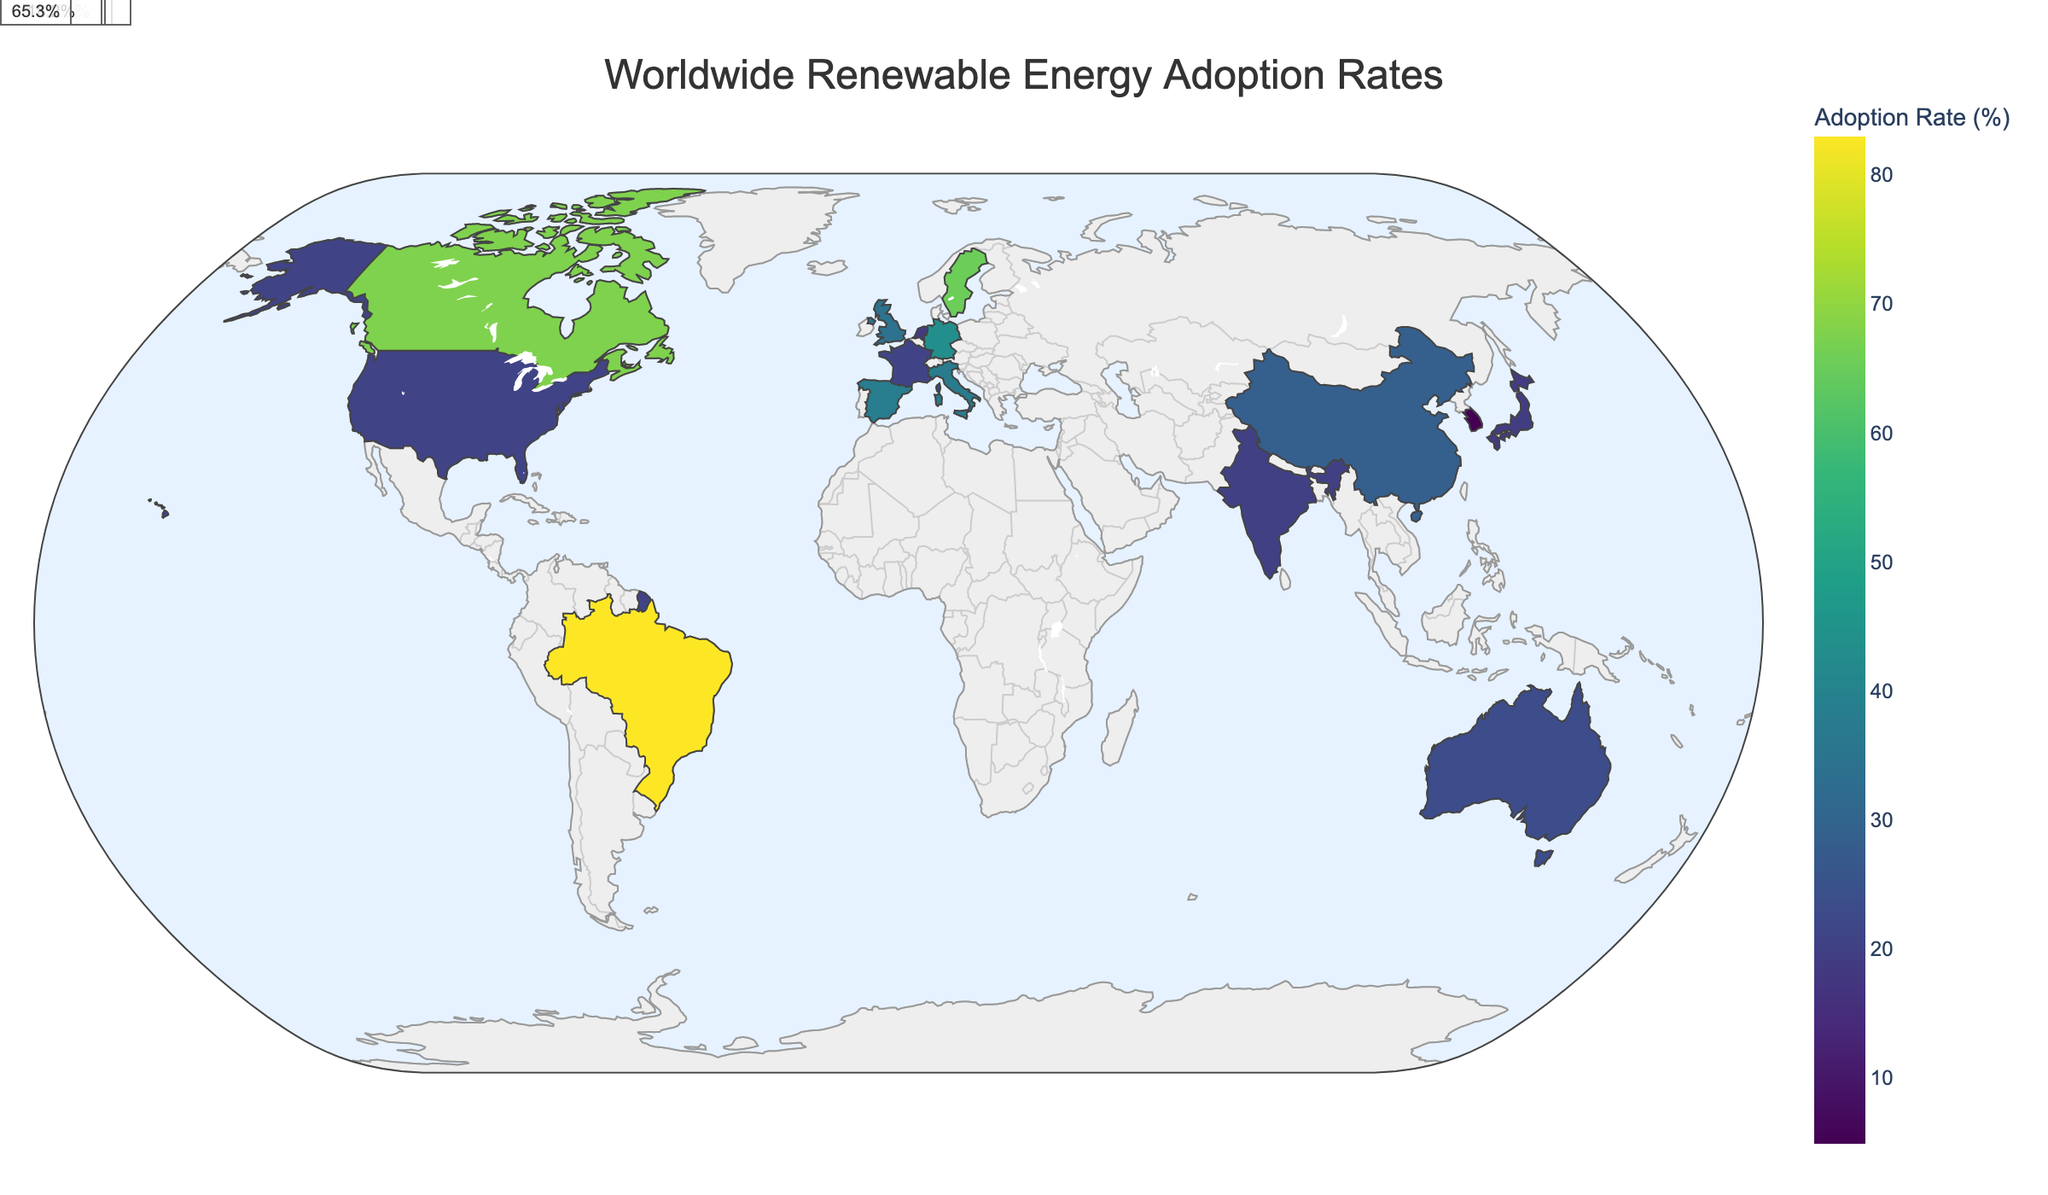what is the title of the figure? The title is positioned at the top of the figure and is intended to provide a brief summary of what the figure is depicting. In this case, it summarizes the geographical map showing renewable energy adoption rates around the world.
Answer: Worldwide Renewable Energy Adoption Rates Which country has the highest total renewable energy adoption rate? To find the highest total renewable energy adoption rate, look at the color intensity and the annotations for total adoption rates. The darker the color, the higher the rate. Brazil appears to have the highest percentage.
Answer: Brazil How does the renewable energy adoption rate of Germany compare to that of the United States? First, locate Germany and the United States on the map. Germany appears to have a more intense color and a higher annotated figure compared to the United States. Germany has a total adoption rate of 43.6%, and the United States has 20.7%.
Answer: Germany has a higher adoption rate What is the average total renewable energy adoption rate of China, India, and Japan? Add up the total renewable energy adoption rates for China (28.4%), India (20.0%), and Japan (18.8%) and then divide by the number of countries (3). (28.4 + 20.0 + 18.8) / 3 = 22.4%
Answer: 22.4% Which countries have a total renewable energy adoption rate below 10%? Look for the countries with lighter colors and annotations showing totals below 10%. South Korea, Canada, and Sweden fit this criterion with annotated totals indicating rates below 10%.
Answer: South Korea, Canada, Sweden Does Italy or Spain have a higher contribution from biomass energy to their renewable energy adoption rate? Examine the specific percentages for biomass energy in the respective countries. Italy has a biomass contribution of 4.1%, whereas Spain has 2.1%.
Answer: Italy has a higher contribution What is the main energy source contributing to Brazil's high renewable energy adoption rate? Look at Brazil's breakdown of energy types. The primary contributor is hydro with a rate of 63.8%.
Answer: Hydro Which country shows a balanced adoption rate across multiple renewable energy types? For a balanced adoption rate, the contributions should be relatively even across various energy types. Germany has significant contributions from solar (8.7%), wind (24.6%), hydro (3.2%), and biomass (7.1%).
Answer: Germany Compare the wind energy adoption rates of the United Kingdom and the Netherlands. Which country has a higher rate? Check the specific adoption rates for wind energy in each country. The United Kingdom has 21.7% and the Netherlands has 11.4%.
Answer: United Kingdom Is there any country with a notable geothermal energy adoption rate? Review the annotated geothermal percentages. Italy stands out with a notable geothermal adoption rate of 1.7%.
Answer: Italy 